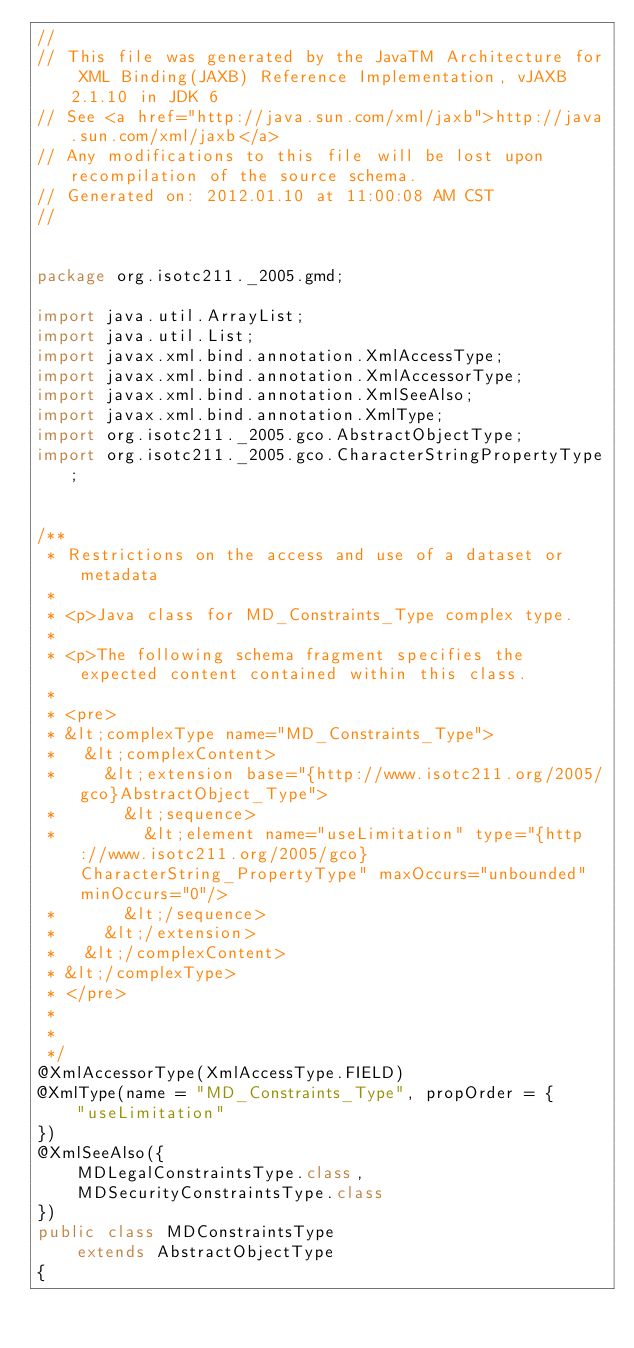<code> <loc_0><loc_0><loc_500><loc_500><_Java_>//
// This file was generated by the JavaTM Architecture for XML Binding(JAXB) Reference Implementation, vJAXB 2.1.10 in JDK 6 
// See <a href="http://java.sun.com/xml/jaxb">http://java.sun.com/xml/jaxb</a> 
// Any modifications to this file will be lost upon recompilation of the source schema. 
// Generated on: 2012.01.10 at 11:00:08 AM CST 
//


package org.isotc211._2005.gmd;

import java.util.ArrayList;
import java.util.List;
import javax.xml.bind.annotation.XmlAccessType;
import javax.xml.bind.annotation.XmlAccessorType;
import javax.xml.bind.annotation.XmlSeeAlso;
import javax.xml.bind.annotation.XmlType;
import org.isotc211._2005.gco.AbstractObjectType;
import org.isotc211._2005.gco.CharacterStringPropertyType;


/**
 * Restrictions on the access and use of a dataset or metadata
 * 
 * <p>Java class for MD_Constraints_Type complex type.
 * 
 * <p>The following schema fragment specifies the expected content contained within this class.
 * 
 * <pre>
 * &lt;complexType name="MD_Constraints_Type">
 *   &lt;complexContent>
 *     &lt;extension base="{http://www.isotc211.org/2005/gco}AbstractObject_Type">
 *       &lt;sequence>
 *         &lt;element name="useLimitation" type="{http://www.isotc211.org/2005/gco}CharacterString_PropertyType" maxOccurs="unbounded" minOccurs="0"/>
 *       &lt;/sequence>
 *     &lt;/extension>
 *   &lt;/complexContent>
 * &lt;/complexType>
 * </pre>
 * 
 * 
 */
@XmlAccessorType(XmlAccessType.FIELD)
@XmlType(name = "MD_Constraints_Type", propOrder = {
    "useLimitation"
})
@XmlSeeAlso({
    MDLegalConstraintsType.class,
    MDSecurityConstraintsType.class
})
public class MDConstraintsType
    extends AbstractObjectType
{
</code> 